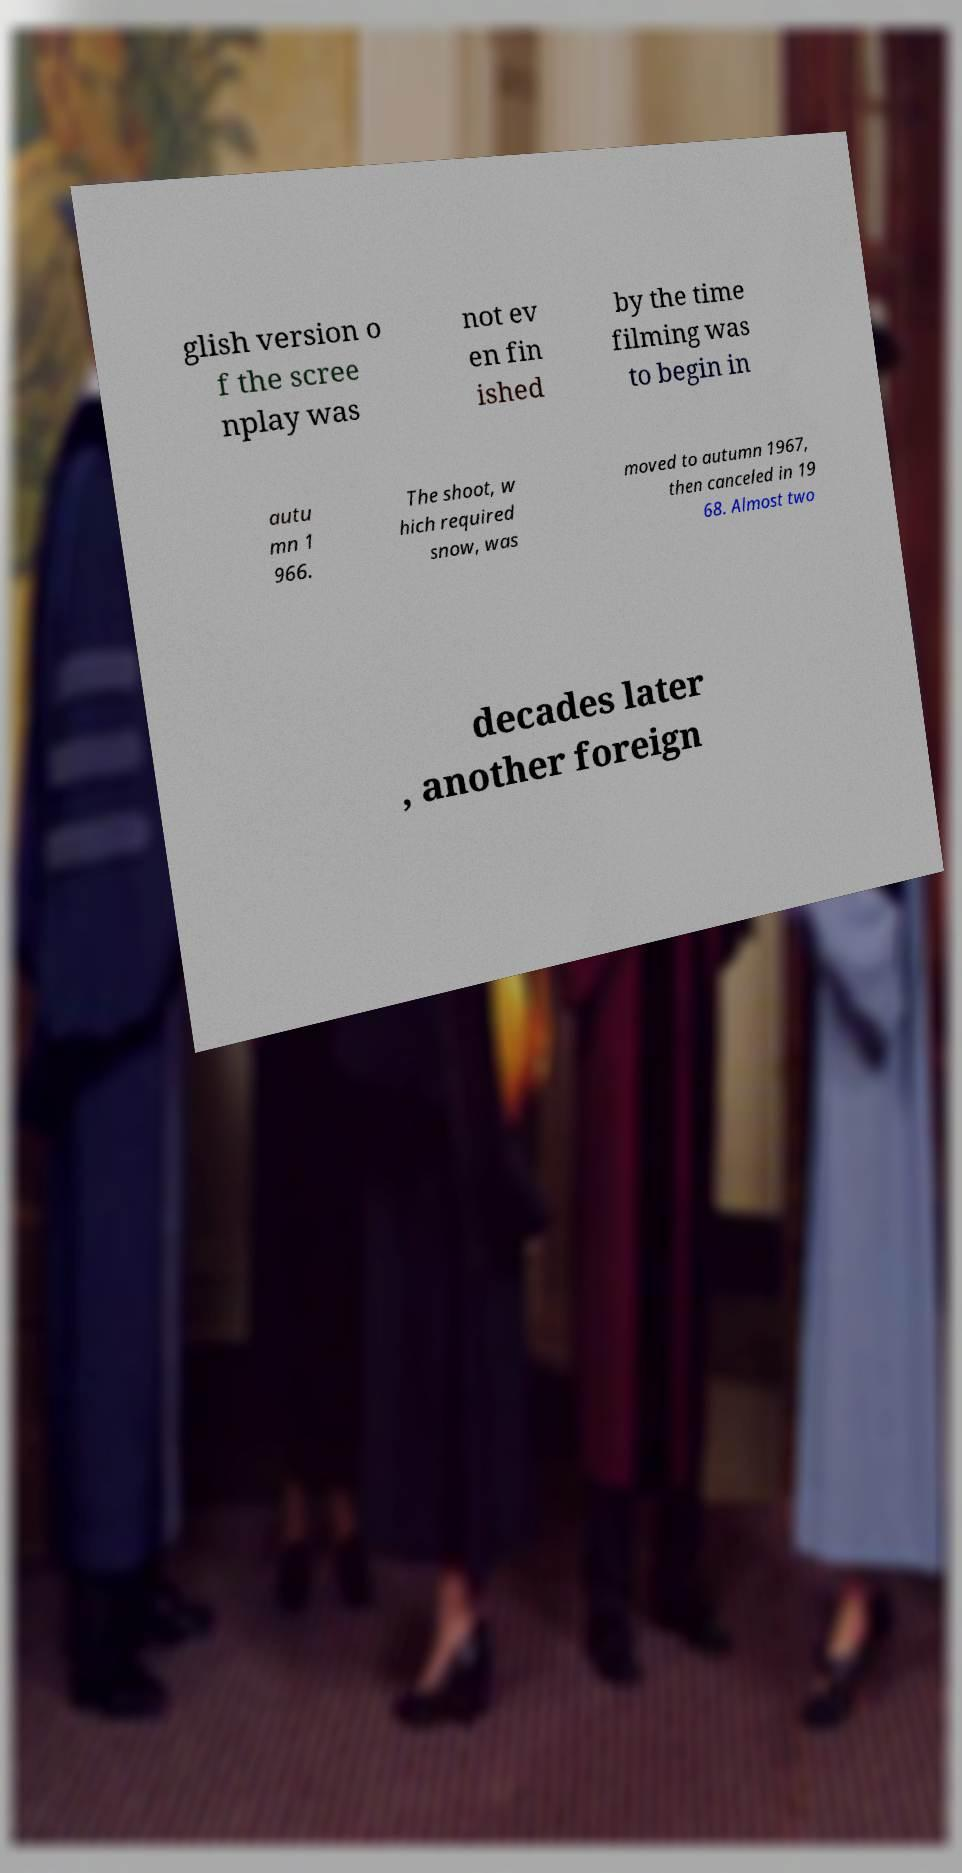There's text embedded in this image that I need extracted. Can you transcribe it verbatim? glish version o f the scree nplay was not ev en fin ished by the time filming was to begin in autu mn 1 966. The shoot, w hich required snow, was moved to autumn 1967, then canceled in 19 68. Almost two decades later , another foreign 